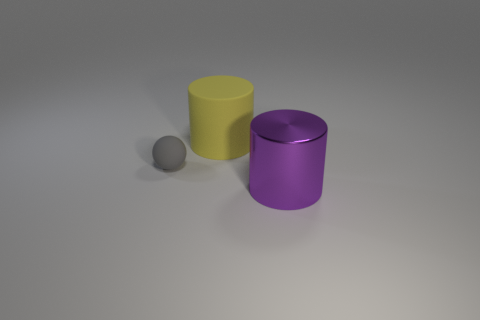Are there any other things that are made of the same material as the purple cylinder?
Ensure brevity in your answer.  No. Is there any other thing that is the same size as the rubber ball?
Provide a short and direct response. No. There is a thing that is in front of the large matte object and to the right of the gray matte sphere; what is its color?
Offer a very short reply. Purple. There is a big object on the left side of the large purple cylinder; what is its material?
Keep it short and to the point. Rubber. What size is the purple cylinder?
Your answer should be compact. Large. How many yellow things are either big shiny cylinders or rubber spheres?
Your response must be concise. 0. How big is the rubber thing in front of the big cylinder to the left of the metal thing?
Give a very brief answer. Small. What number of other things are there of the same material as the large purple thing
Keep it short and to the point. 0. There is a big yellow thing that is made of the same material as the small gray ball; what is its shape?
Ensure brevity in your answer.  Cylinder. Is there anything else of the same color as the small object?
Your answer should be very brief. No. 